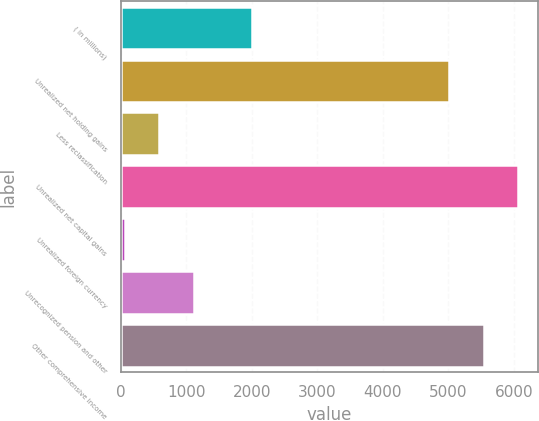<chart> <loc_0><loc_0><loc_500><loc_500><bar_chart><fcel>( in millions)<fcel>Unrealized net holding gains<fcel>Less reclassification<fcel>Unrealized net capital gains<fcel>Unrealized foreign currency<fcel>Unrecognized pension and other<fcel>Other comprehensive income<nl><fcel>2009<fcel>5015<fcel>586.6<fcel>6062.2<fcel>63<fcel>1110.2<fcel>5538.6<nl></chart> 